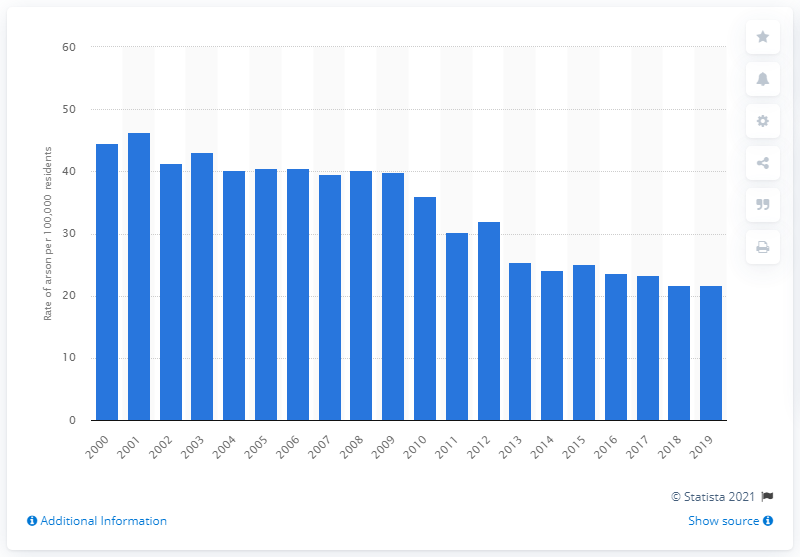Outline some significant characteristics in this image. In 2019, the arson rate per 100,000 residents in Canada was 21.79. 